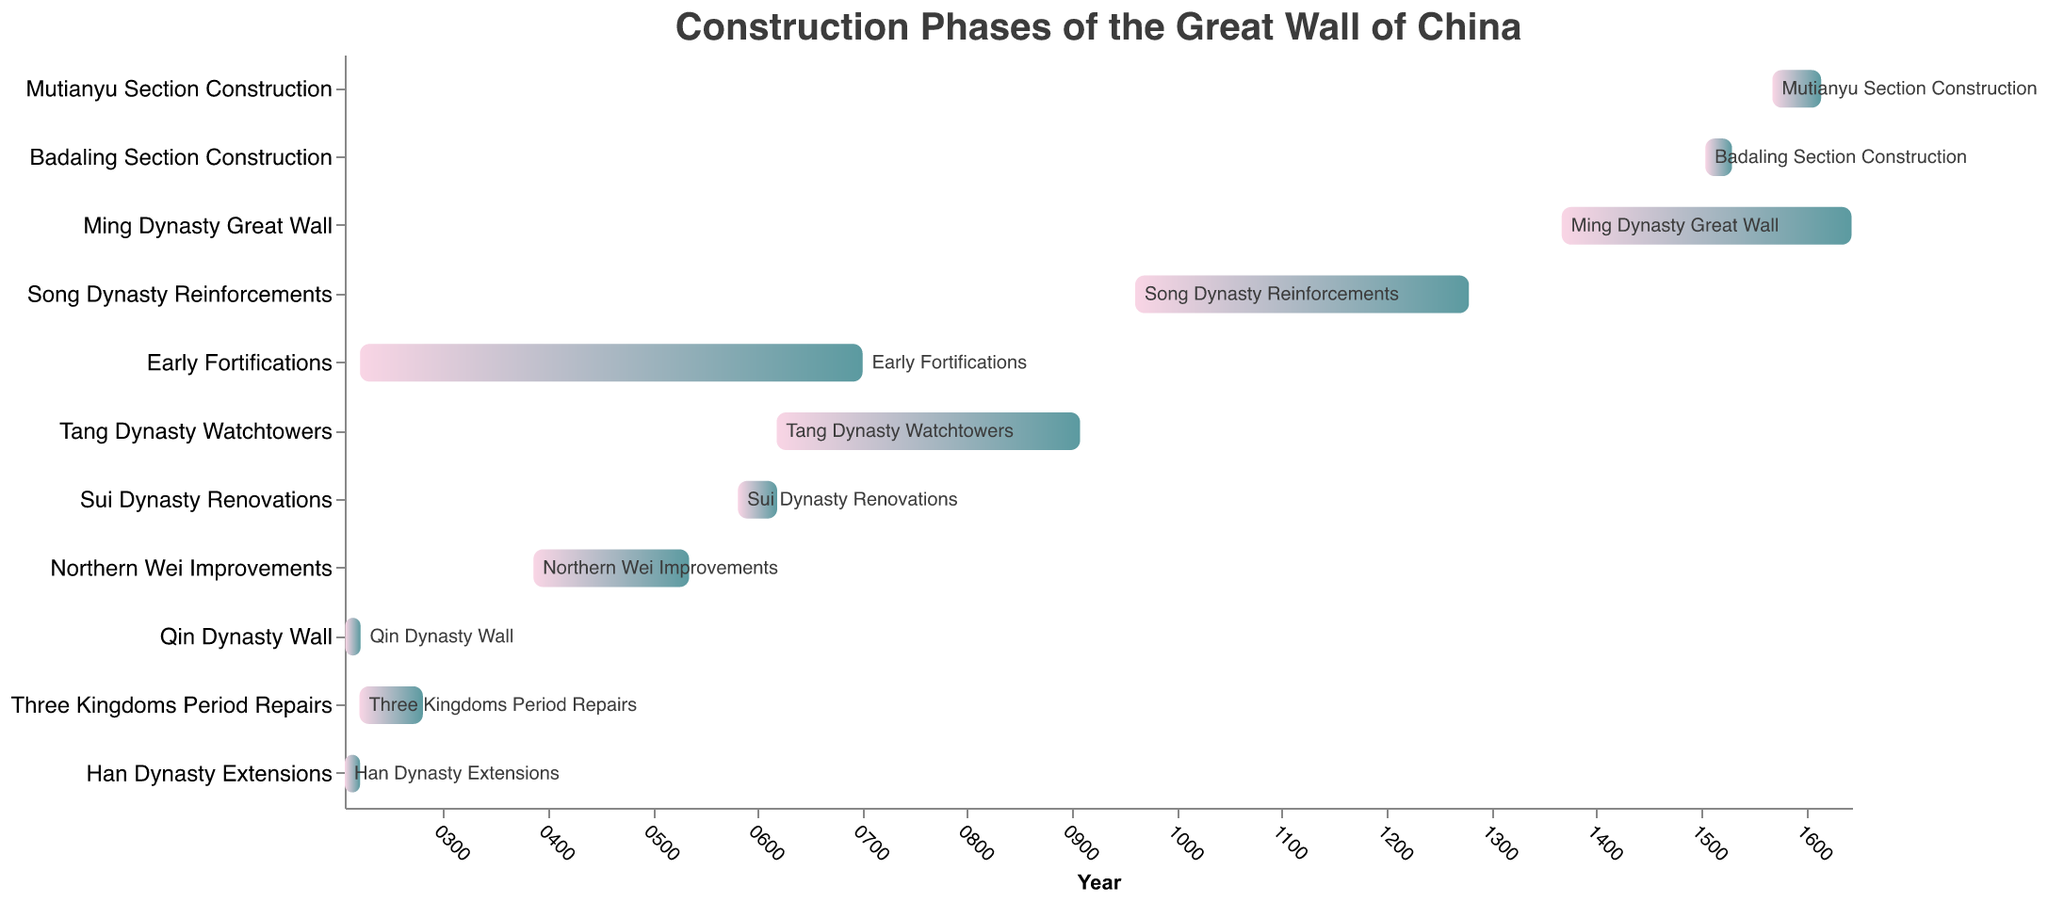What is the title of the chart? The title is displayed at the top of the chart and is often used to summarize the content of the figure.
Answer: Construction Phases of the Great Wall of China Which construction phase started first? By looking at the start dates on the x-axis and comparing those, the task that begins the earliest is identifiable.
Answer: Early Fortifications Which phase lasted the longest? To determine this, you compare the duration each phase spans from its start to end year. The longest duration indicates the longest phase.
Answer: Early Fortifications What is the color gradient used in the bars? The bars use a gradient that transitions from one color to another. The specific colors are extracted by observing the visual gradient.
Answer: From pink to teal How long did the Han Dynasty Extensions last? By subtracting the start year from the end year for the Han Dynasty Extensions phase, the duration is calculated.
Answer: 426 years During which dynasty was the Badaling Section constructed? Observing the overlapping time periods in the chart helps identify the dynasty under which the Badaling Section falls.
Answer: Ming Dynasty Which phase ended in 907 AD? By identifying the end date of 907 AD from the bars, the corresponding task can be determined.
Answer: Tang Dynasty Watchtowers Did the construction phase of the Song Dynasty Reinforcements overlap with the Tang Dynasty Watchtowers? Comparing the start and end years of these two phases will indicate if there's any overlap.
Answer: No Which construction phase had the shortest duration? The phase with the smallest difference between its start and end dates can be identified as the shortest.
Answer: Badaling Section Construction How many phases took place after 1000 AD? By counting the number of tasks that start after the year 1000 AD, this can be determined.
Answer: Four 